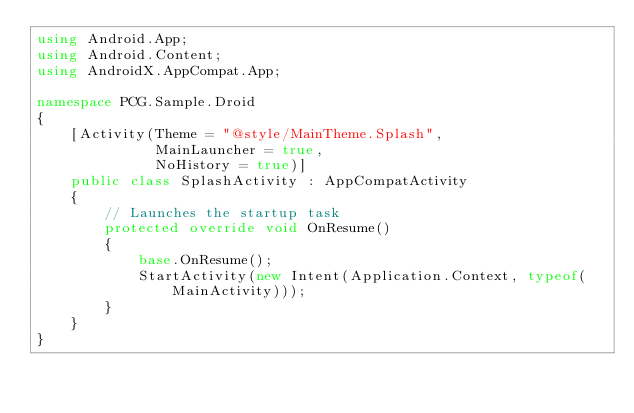Convert code to text. <code><loc_0><loc_0><loc_500><loc_500><_C#_>using Android.App;
using Android.Content;
using AndroidX.AppCompat.App;

namespace PCG.Sample.Droid
{
    [Activity(Theme = "@style/MainTheme.Splash",
              MainLauncher = true,
              NoHistory = true)]
    public class SplashActivity : AppCompatActivity
    {
        // Launches the startup task
        protected override void OnResume()
        {
            base.OnResume();
            StartActivity(new Intent(Application.Context, typeof(MainActivity)));
        }
    }
}
</code> 